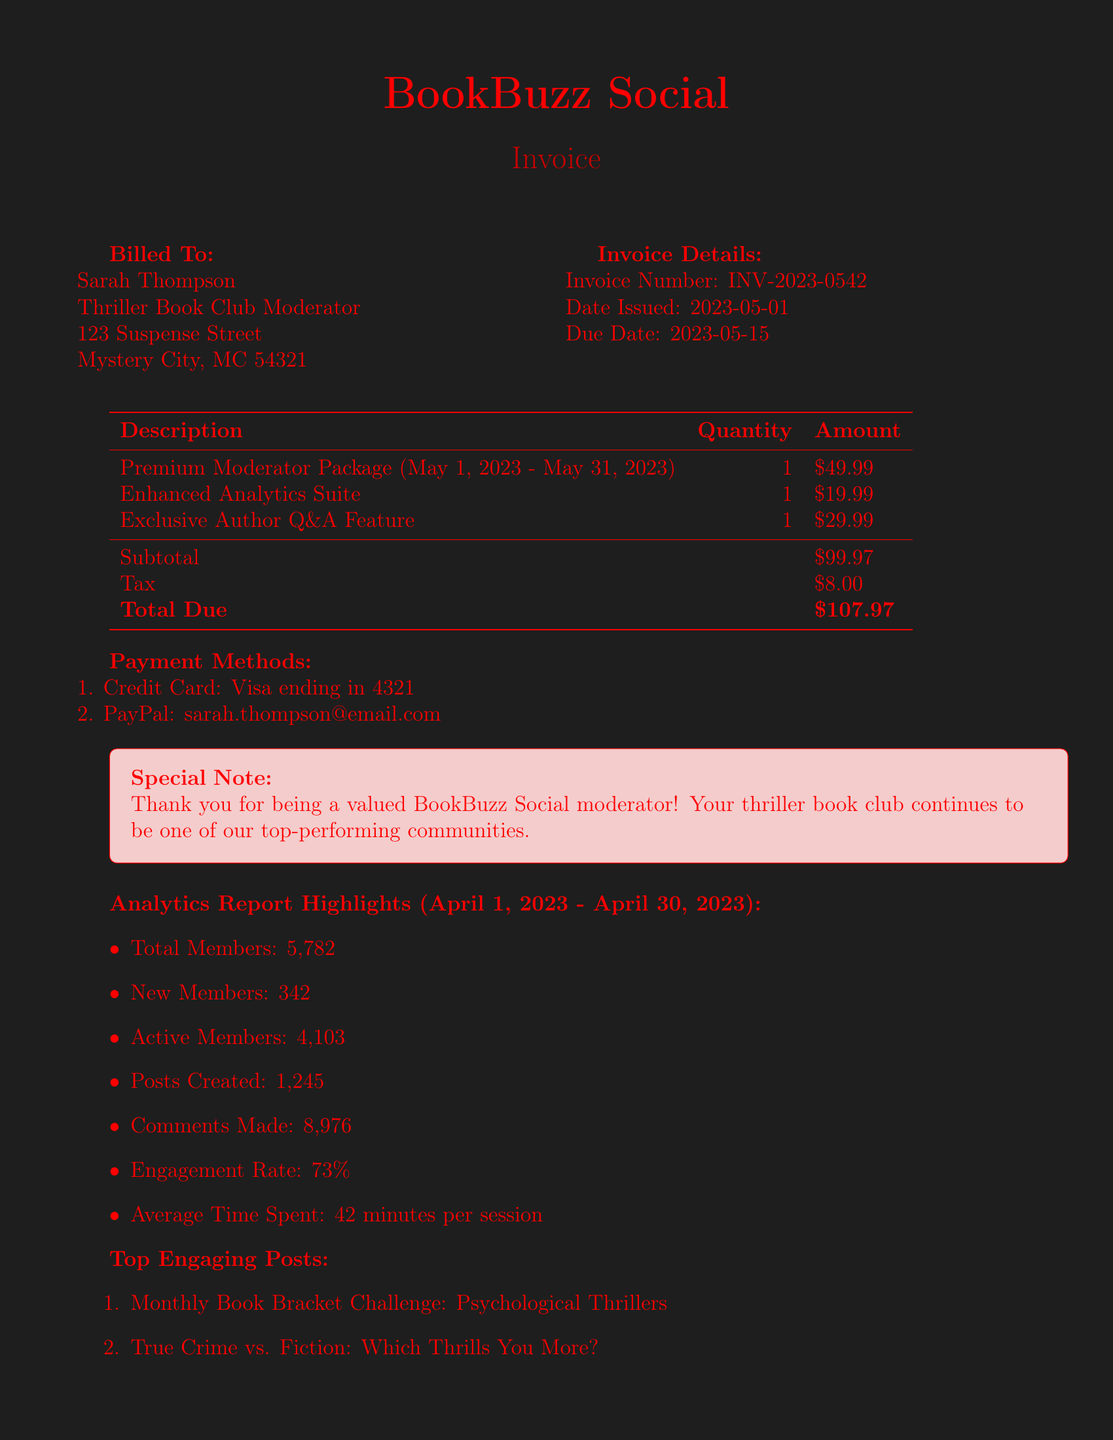What is the invoice number? The invoice number is a specific identifier assigned to the invoice, which is located in the document.
Answer: INV-2023-0542 What is the due date? The due date signifies when the payment is expected and is clearly stated in the document.
Answer: 2023-05-15 What is the total due amount? The total due represents the complete payment required, which is found at the end of the invoice.
Answer: $107.97 How many new members joined during the report period? The number of new members is reported in the analytics section, indicating growth in the club membership.
Answer: 342 What percentage of members are aged 25-34? This percentage is provided in the member demographics section to illustrate member age distribution.
Answer: 32% What is the name of the company that issued the invoice? The company name is located in the header section of the document, identifying the service provider.
Answer: BookBuzz Social What was included in the Enhanced Analytics Suite? This add-on service description is present in the subscription details with its specific focus.
Answer: Advanced engagement metrics for thriller genre How many total members were there during the report period? The total member count is crucial for understanding the community size, indicated in the analytics report.
Answer: 5782 What method of payment is available besides PayPal? The document lists available payment options, including alternative methods.
Answer: Credit Card 